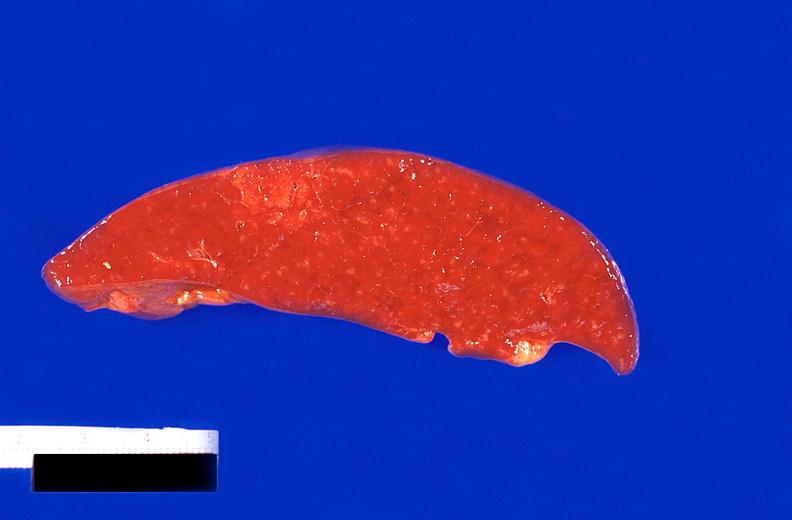where is this part in?
Answer the question using a single word or phrase. Spleen 